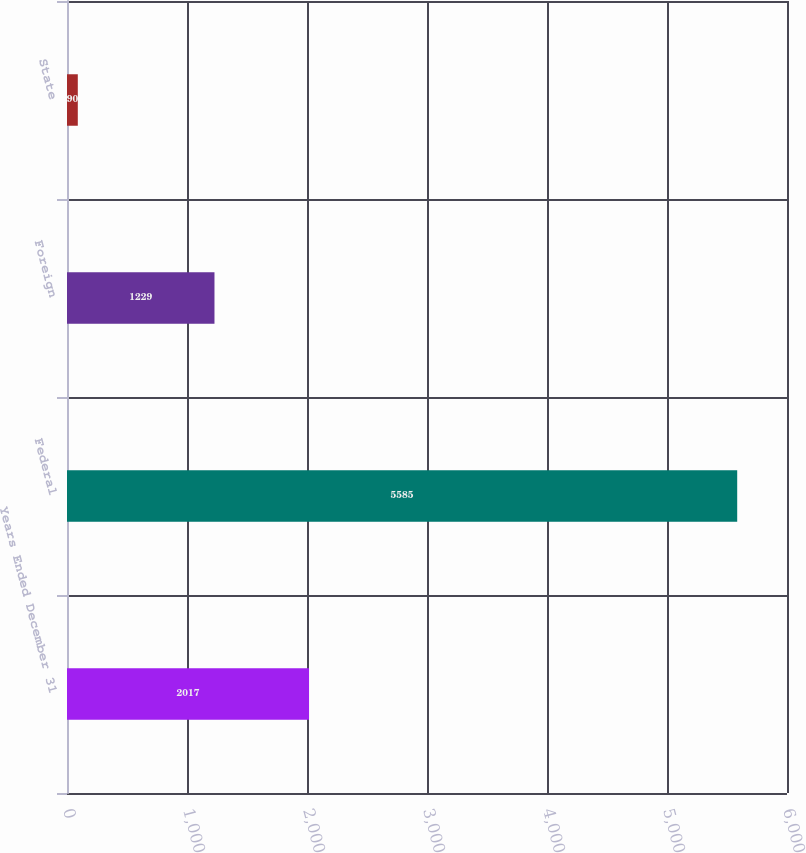Convert chart to OTSL. <chart><loc_0><loc_0><loc_500><loc_500><bar_chart><fcel>Years Ended December 31<fcel>Federal<fcel>Foreign<fcel>State<nl><fcel>2017<fcel>5585<fcel>1229<fcel>90<nl></chart> 